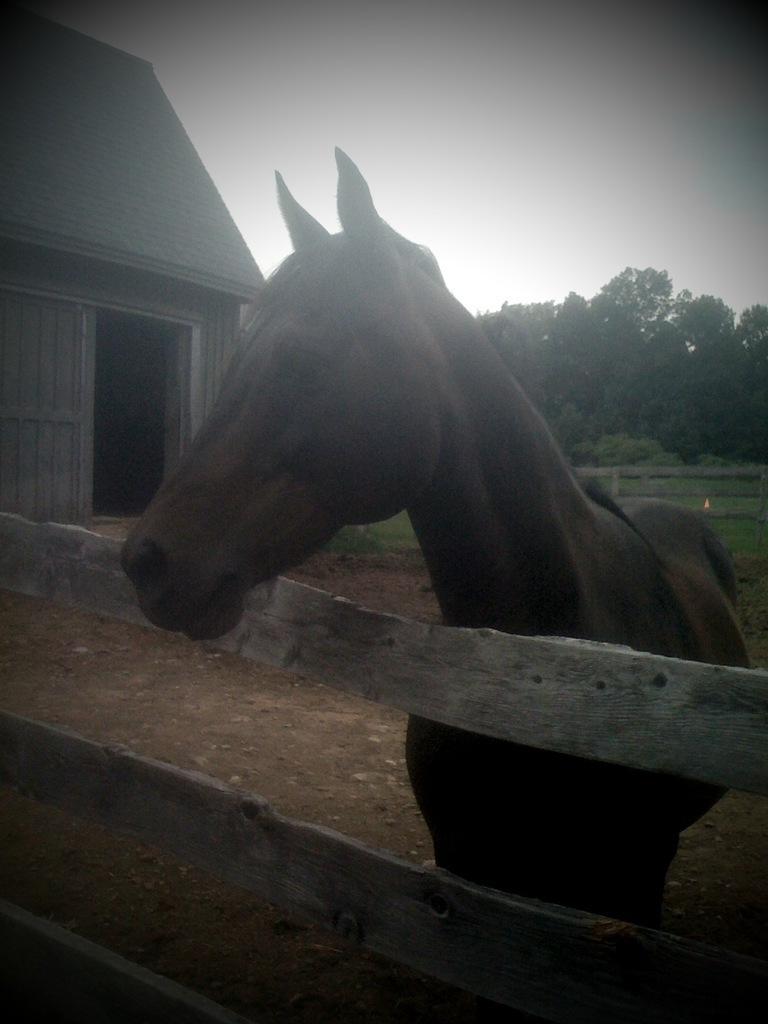How would you summarize this image in a sentence or two? In this image I can see an animal which is in brown color. It is standing on the ground. In-front of the animal I can see the wooden railing. To the left there is a shed. In the back I can see many trees and the white sky. 